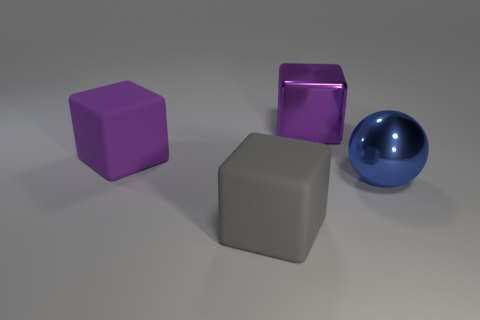What material is the large sphere?
Offer a very short reply. Metal. Are there more purple metallic cubes than large things?
Offer a very short reply. No. Do the purple matte object and the gray rubber thing have the same shape?
Your answer should be compact. Yes. Are there any other things that have the same shape as the big gray thing?
Your response must be concise. Yes. Is the color of the large metal thing on the left side of the large ball the same as the block to the left of the big gray rubber cube?
Keep it short and to the point. Yes. Is the number of large purple metal cubes on the left side of the gray thing less than the number of big gray blocks in front of the blue metallic sphere?
Your answer should be very brief. Yes. There is a purple thing in front of the big shiny block; what shape is it?
Provide a short and direct response. Cube. There is another cube that is the same color as the metallic cube; what is it made of?
Keep it short and to the point. Rubber. What number of other objects are there of the same material as the sphere?
Your answer should be compact. 1. There is a gray rubber object; is it the same shape as the shiny object to the left of the large blue object?
Offer a very short reply. Yes. 